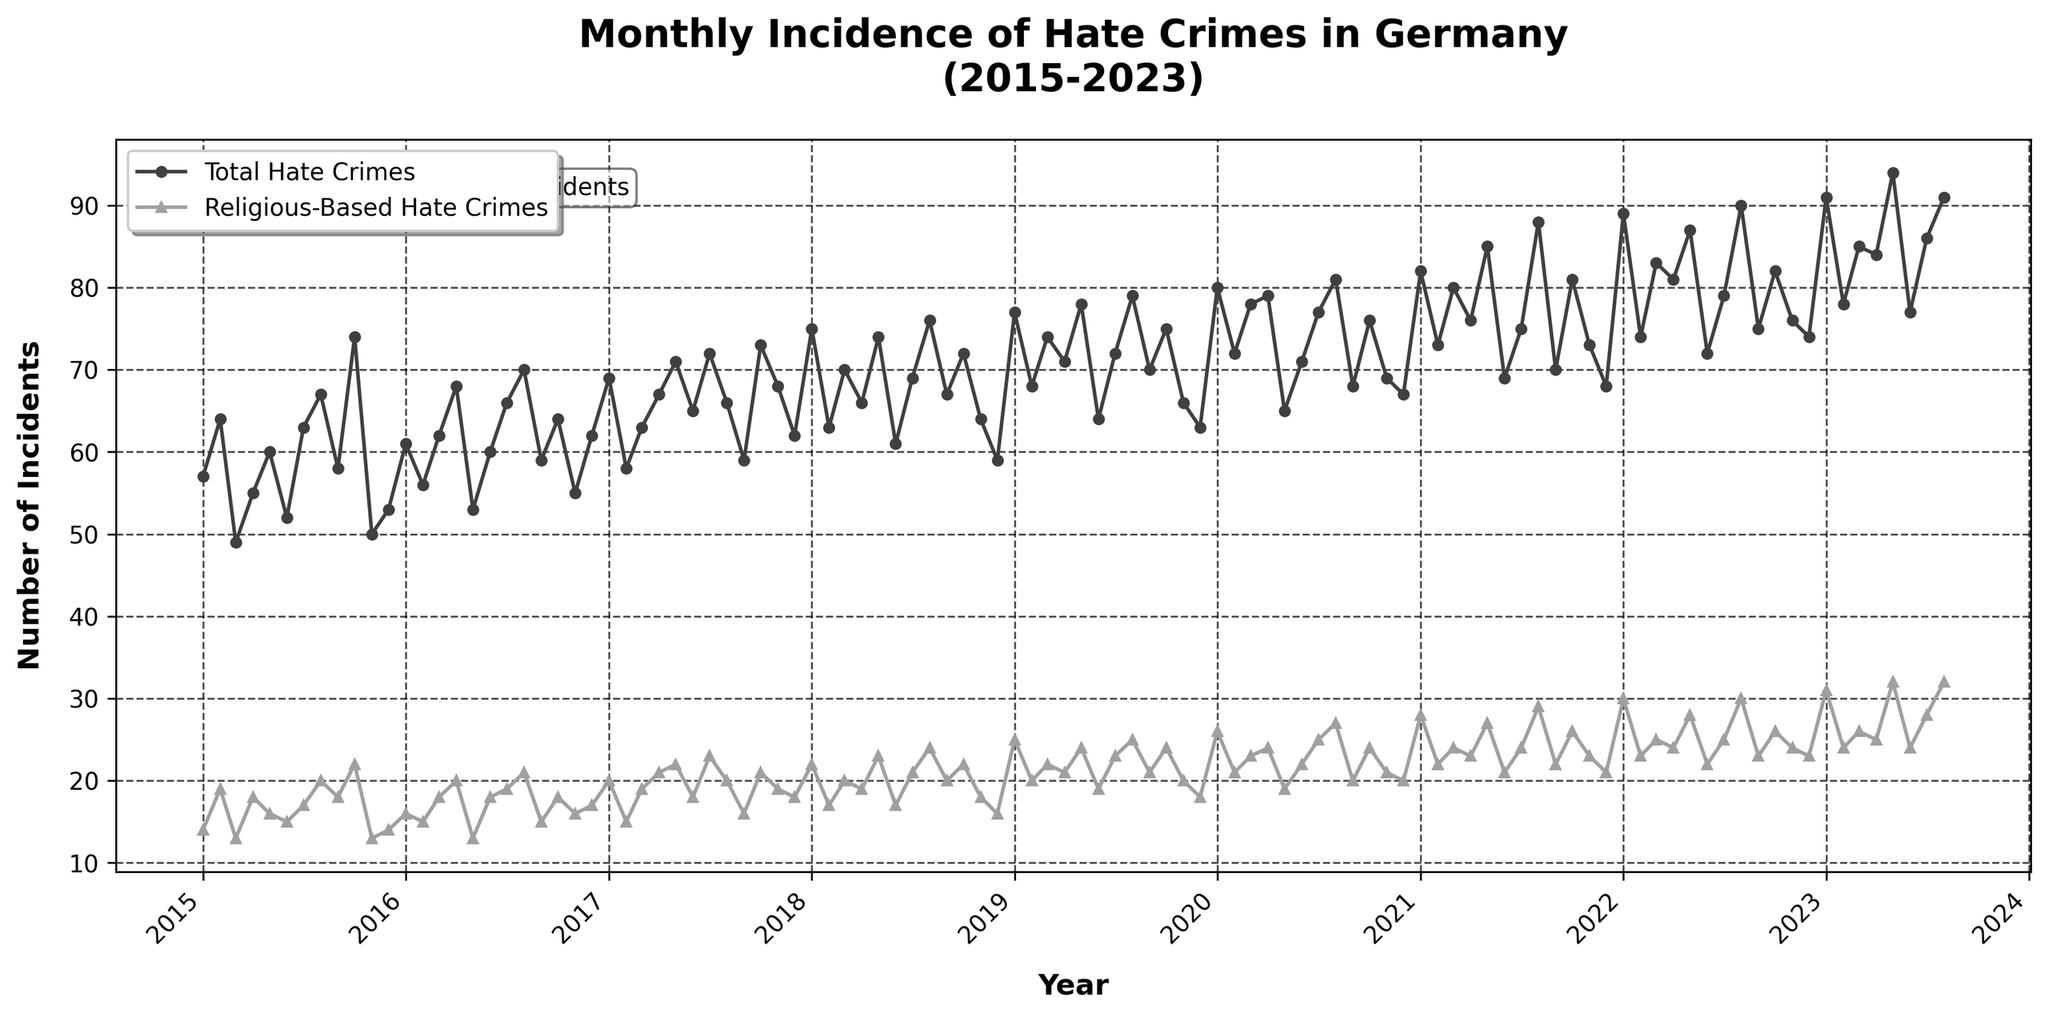What is the title of the plot? The title is located at the top of the plot and usually describes what the plot is about. Here, the title is "Monthly Incidence of Hate Crimes in Germany (2015-2023)."
Answer: Monthly Incidence of Hate Crimes in Germany (2015-2023) What color represents the Religious-Based Hate Crimes in the plot? The Religious-Based Hate Crimes are marked with a color that stands out from the Total Hate Crimes. In the plot, the Religious-Based Hate Crimes are represented by a lighter shade of gray.
Answer: Lighter gray How does the trend of Total Hate Crimes from 2015 to 2023 compare visually to the trend of Religious-Based Hate Crimes? The trends for both types of hate crimes can be observed by looking at the overall direction of the lines representing them. Initially, both lines have an upward trend, but the Total Hate Crimes line has more pronounced peaks and valleys, while the Religious-Based Hate Crimes show a more gradual, consistent increase.
Answer: Both increase, but Total Hate Crimes have more pronounced fluctuations How many incidents of Total Hate Crimes were recorded in January 2019? Look for the point corresponding to January 2019 on the x-axis and check the y-axis value for the Total Hate Crimes line. In January 2019, the Total Hate Crimes line hits the y-axis value between 75 and 80.
Answer: 77 Which year saw the highest monthly reported Religious-Based Hate Crimes? To find the highest monthly value for Religious-Based Hate Crimes, look at the light gray line for its peak point. The highest point on this line occurs in August 2022 with a value of 30.
Answer: 2022 By how much did the Total Hate Crimes increase from January 2015 to January 2023? Find the y-axis value for Total Hate Crimes in January 2015, which is 57, and in January 2023, which is 91. Then subtract the earlier value from the later value: 91 - 57. The increase is 34.
Answer: 34 In which month and year did both Total and Religious-Based Hate Crimes peak together? Identify the month and year where both lines are at a high point simultaneously. The plot shows that in August 2022, both lines are at or near their peaks with 90 Total Hate Crimes and 30 Religious-Based Hate Crimes.
Answer: August 2022 What is the average number of Total Hate Crimes per month in 2022? Identify all data points for Total Hate Crimes in 2022 and calculate their sum: 89 (Jan) + 74 (Feb) + 83 (Mar) + 81 (Apr) + 87 (May) + 72 (Jun) + 79 (Jul) + 90 (Aug) + 75 (Sep) + 82 (Oct) + 76 (Nov) + 74 (Dec) = 962. Divide by the number of months: 962 / 12.
Answer: 80.2 What can be inferred from the text box titled "Focus on Religious-based Incidents"? This text box is located within the plot and provides viewers with additional context. It highlights that the plot has a special emphasis on religious-based hate crime incidents, guiding the viewer’s attention to that aspect.
Answer: Emphasis on religious-based incidents 